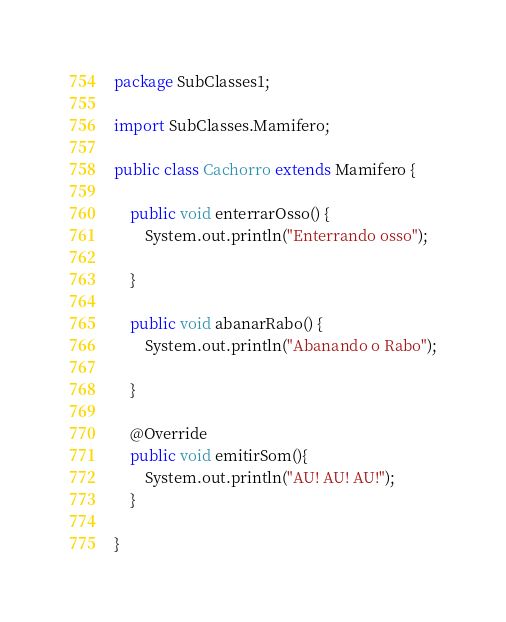Convert code to text. <code><loc_0><loc_0><loc_500><loc_500><_Java_>package SubClasses1;

import SubClasses.Mamifero;

public class Cachorro extends Mamifero {

    public void enterrarOsso() {
        System.out.println("Enterrando osso");

    }

    public void abanarRabo() {
        System.out.println("Abanando o Rabo");

    }
    
    @Override
    public void emitirSom(){
        System.out.println("AU! AU! AU!");
    }

}
</code> 